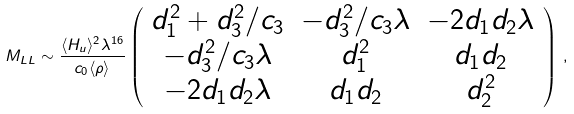<formula> <loc_0><loc_0><loc_500><loc_500>M _ { L L } \sim \frac { \langle H _ { u } \rangle ^ { 2 } \lambda ^ { 1 6 } } { c _ { 0 } \langle \rho \rangle } \left ( \begin{array} { c c c } d _ { 1 } ^ { 2 } + d _ { 3 } ^ { 2 } / c _ { 3 } & - d _ { 3 } ^ { 2 } / c _ { 3 } \lambda & - 2 d _ { 1 } d _ { 2 } \lambda \\ - d _ { 3 } ^ { 2 } / c _ { 3 } \lambda & d _ { 1 } ^ { 2 } & d _ { 1 } d _ { 2 } \\ - 2 d _ { 1 } d _ { 2 } \lambda & d _ { 1 } d _ { 2 } & d _ { 2 } ^ { 2 } \end{array} \right ) \, ,</formula> 